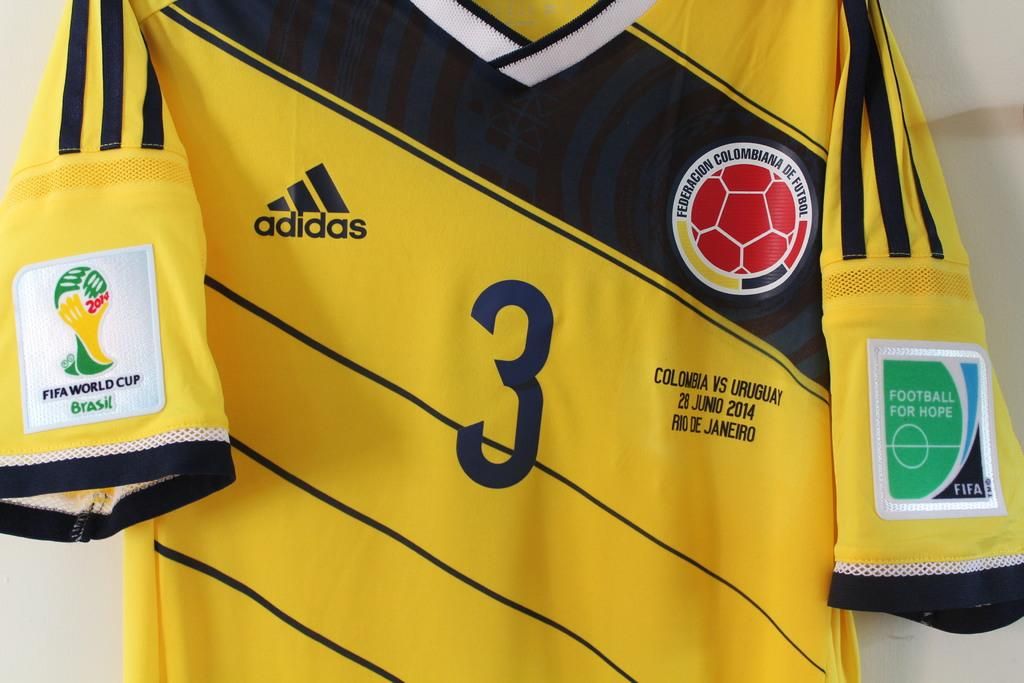Provide a one-sentence caption for the provided image. a yellow and blue adidas shirt with number 3 on the front. 